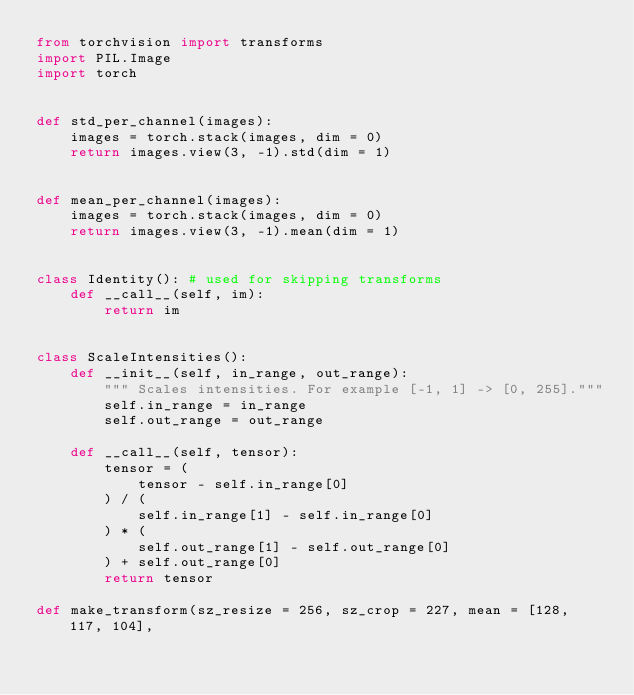Convert code to text. <code><loc_0><loc_0><loc_500><loc_500><_Python_>from torchvision import transforms
import PIL.Image
import torch


def std_per_channel(images):
    images = torch.stack(images, dim = 0)
    return images.view(3, -1).std(dim = 1)


def mean_per_channel(images):
    images = torch.stack(images, dim = 0)
    return images.view(3, -1).mean(dim = 1)


class Identity(): # used for skipping transforms
    def __call__(self, im):
        return im


class ScaleIntensities():
    def __init__(self, in_range, out_range):
        """ Scales intensities. For example [-1, 1] -> [0, 255]."""
        self.in_range = in_range
        self.out_range = out_range

    def __call__(self, tensor):
        tensor = (
            tensor - self.in_range[0]
        ) / (
            self.in_range[1] - self.in_range[0]
        ) * (
            self.out_range[1] - self.out_range[0]
        ) + self.out_range[0]
        return tensor

def make_transform(sz_resize = 256, sz_crop = 227, mean = [128, 117, 104], </code> 